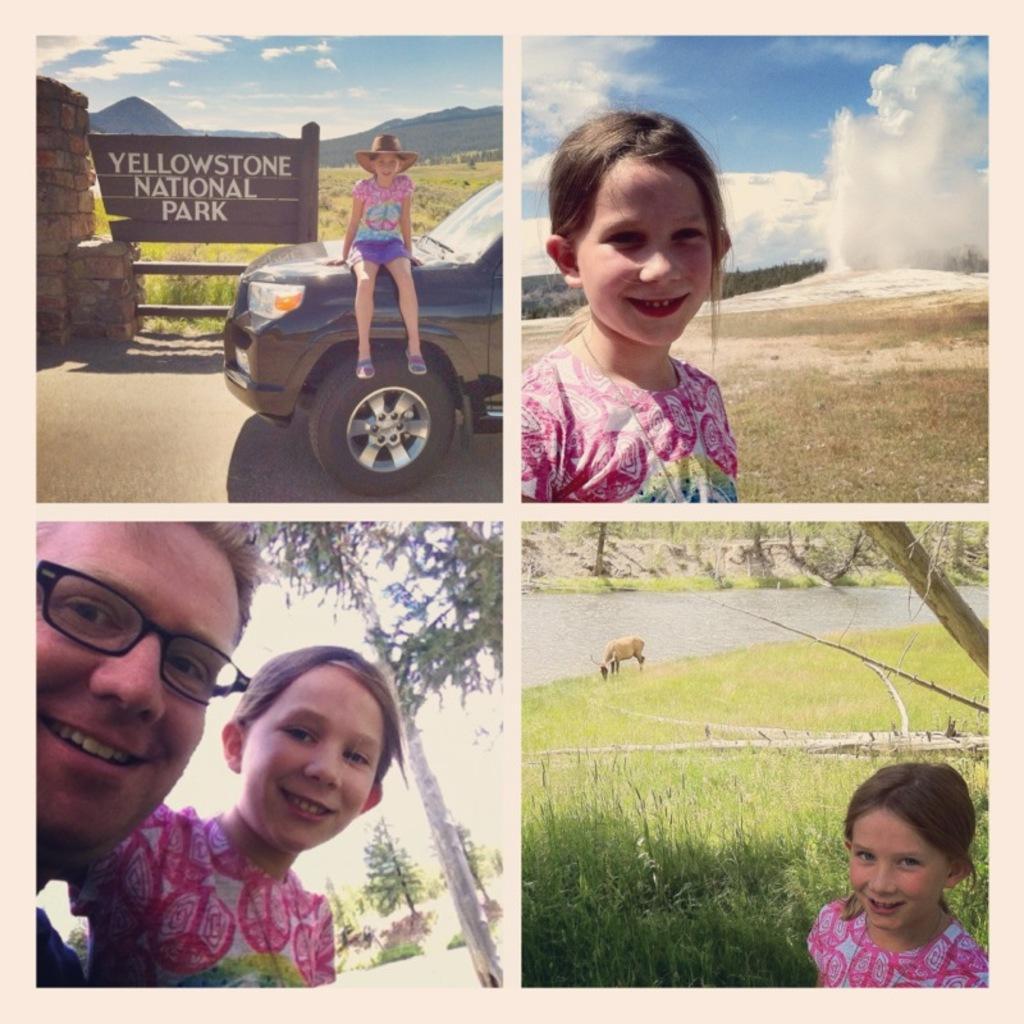Describe this image in one or two sentences. This picture is an edited picture. In the top left there is a girl sitting on the car and at the back there are mountains and at the top there is sky and there are clouds and there is a board and there is a text on the board. In the top right there is a girl standing and smiling and at the back there are trees. In the bottom left there are two persons smiling and at the back there are trees. In the bottom right there is a girl standing and smiling and at the back there are trees and there is water and there is an animal standing on the grass. 